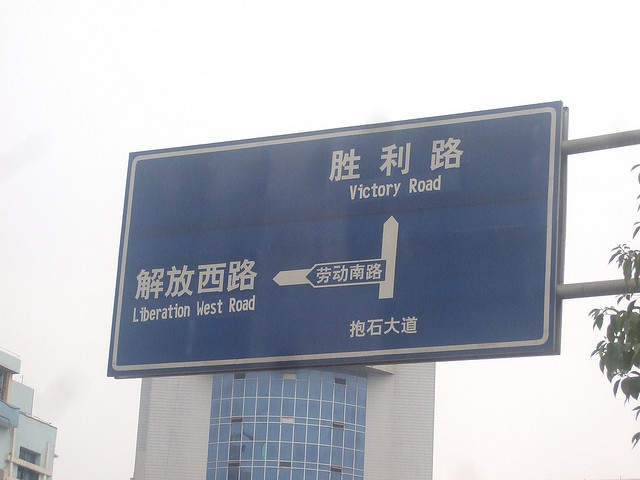Describe the objects in this image and their specific colors. I can see various objects in this image with different colors. 